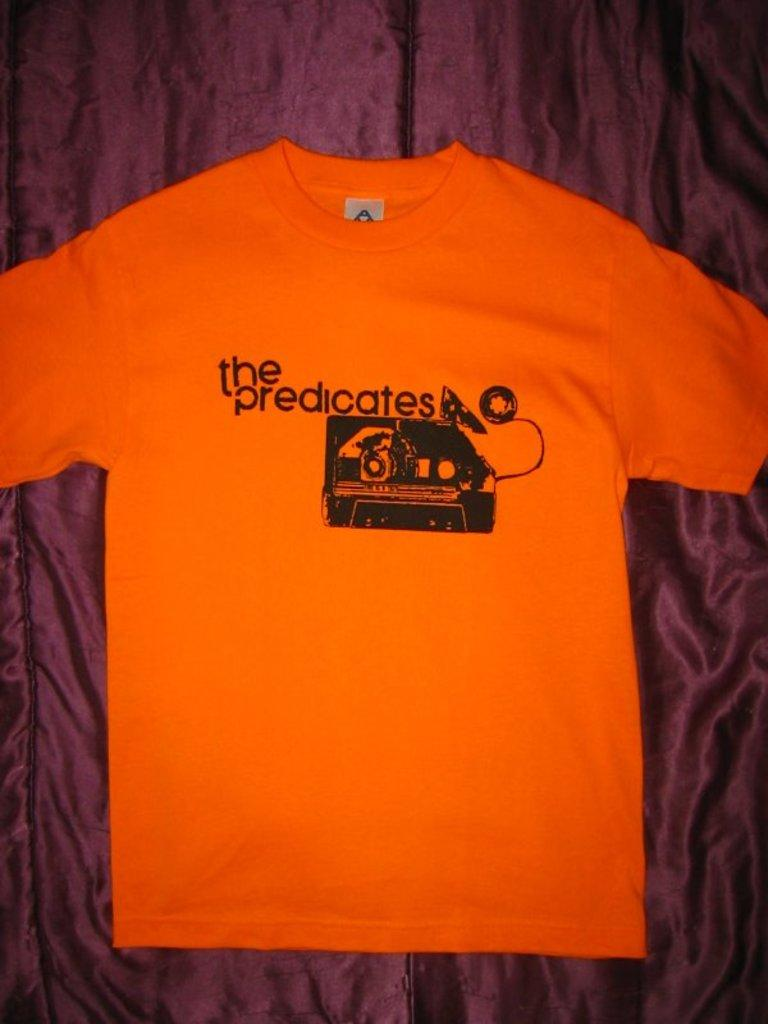What type of clothing item is in the image? There is a shirt in the image. What color is the shirt? The shirt is in orange color. What is the color of the background in the image? There is a brown color background in the image. What type of collar is on the shirt in the image? The image does not show the collar of the shirt, as it only shows the orange shirt against a brown background. 